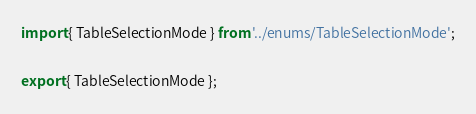Convert code to text. <code><loc_0><loc_0><loc_500><loc_500><_TypeScript_>import { TableSelectionMode } from '../enums/TableSelectionMode';

export { TableSelectionMode };
</code> 